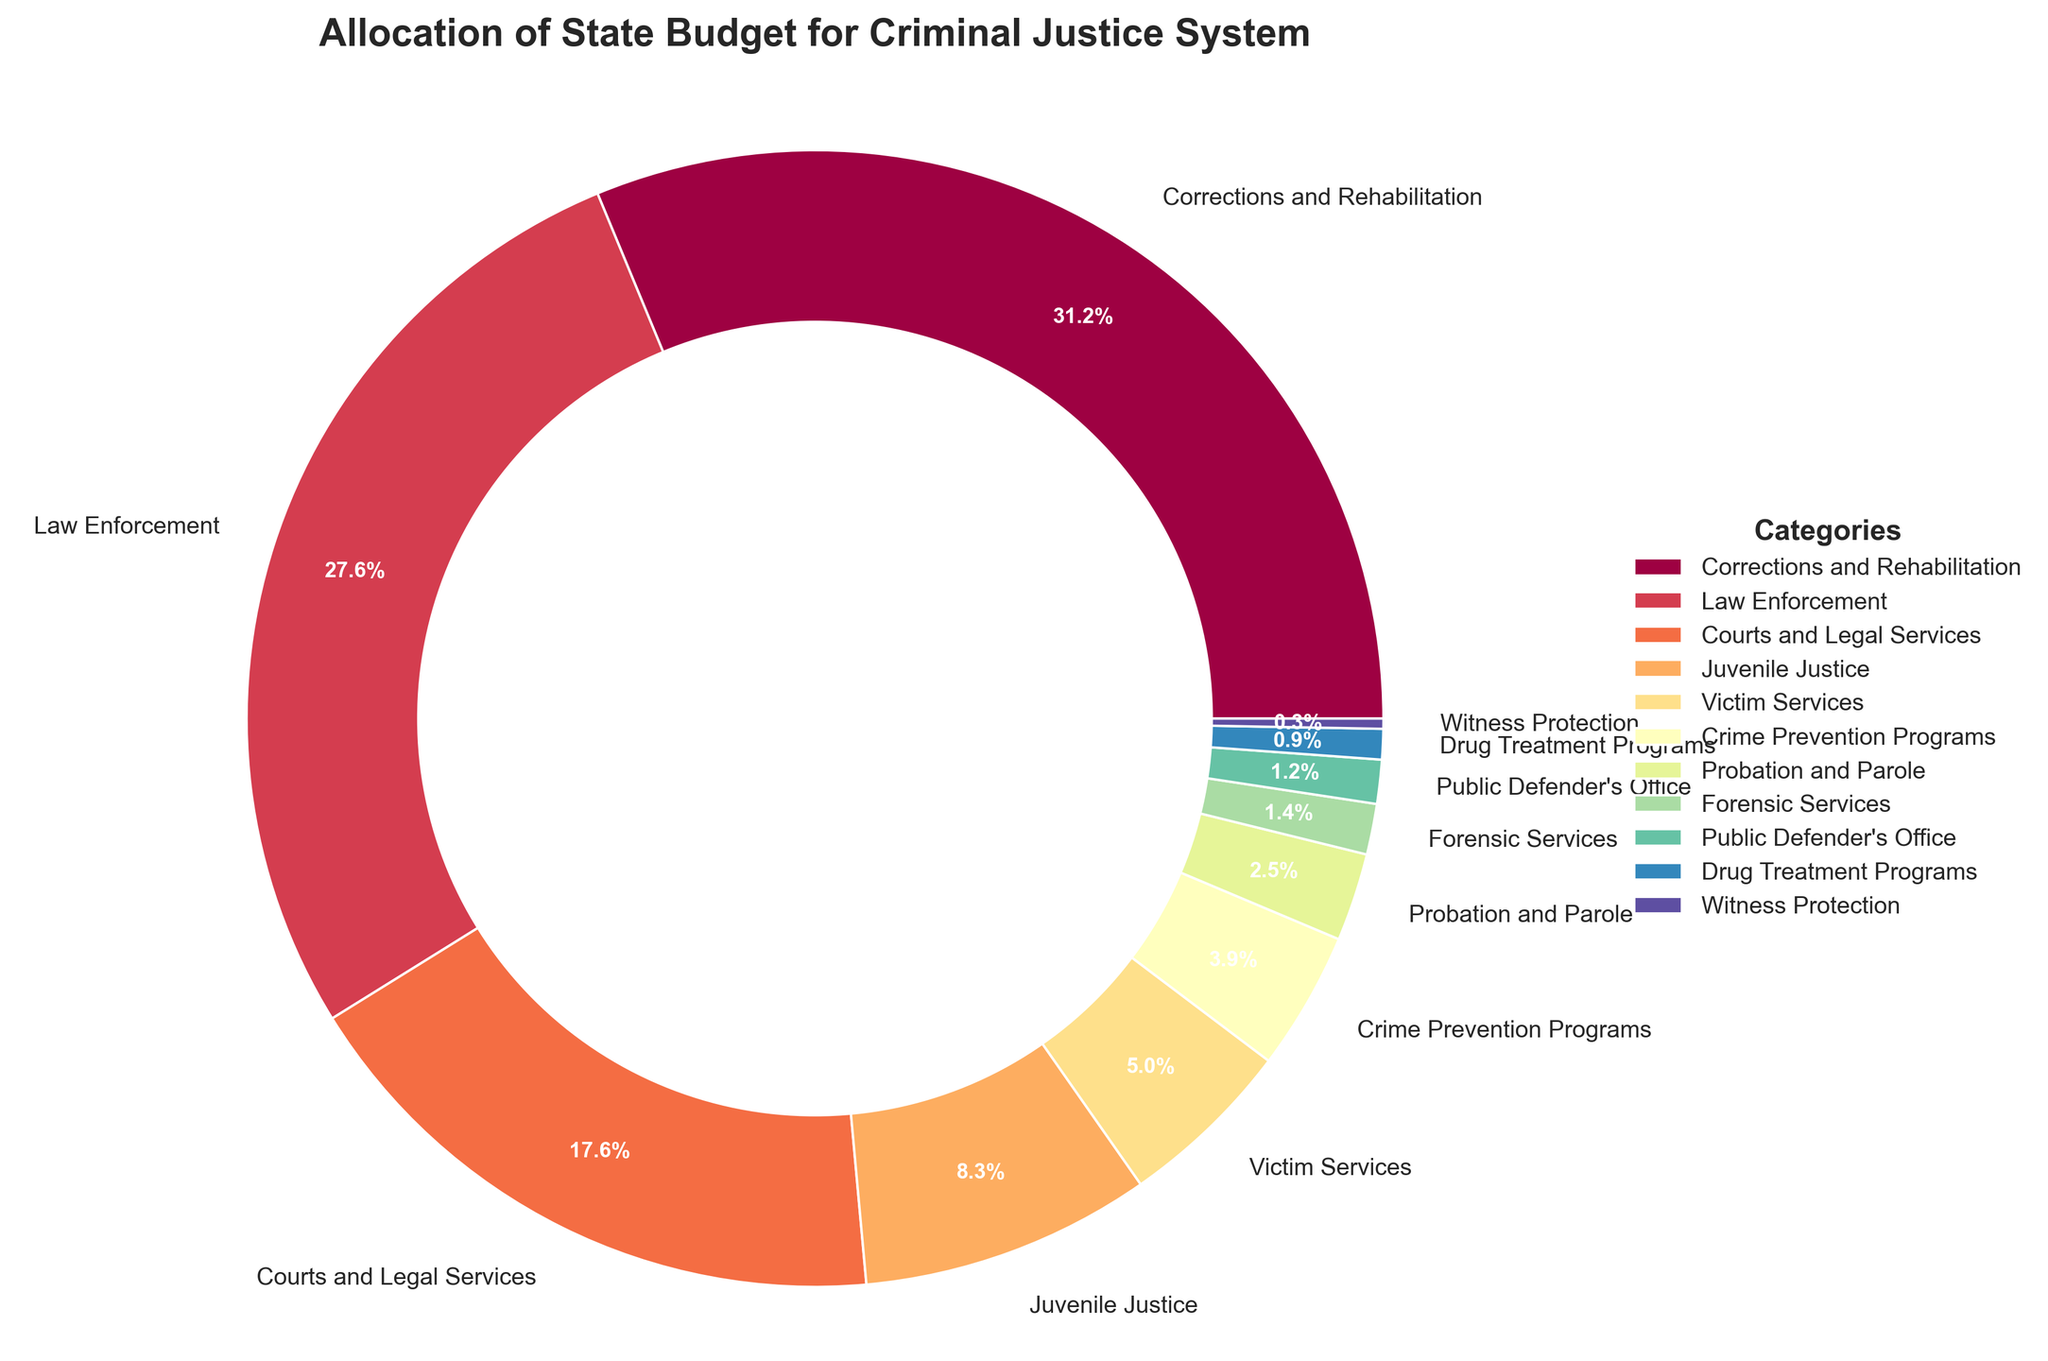What's the largest allocation in the state budget for the criminal justice system? The figure shows that "Corrections and Rehabilitation" has the largest slice of the pie chart with a percentage of 32.5%.
Answer: Corrections and Rehabilitation What is the total percentage allocated to law enforcement and courts and legal services combined? From the figure, Law Enforcement is 28.7% and Courts and Legal Services is 18.3%. Adding these two percentages gives 28.7 + 18.3 = 47%.
Answer: 47% Which category has the smallest allocation, and what is its percentage? According to the figure, "Witness Protection" has the smallest slice of the pie chart with a percentage of 0.3%.
Answer: Witness Protection, 0.3% How much more is allocated to juvenile justice than to probation and parole? Juvenile Justice has an allocation of 8.6%, while Probation and Parole has 2.6%. Subtracting these gives 8.6 - 2.6 = 6%.
Answer: 6% Which category has the second-highest allocation, and what is its percentage? The second-largest slice in the pie chart is "Law Enforcement" with a percentage of 28.7%.
Answer: Law Enforcement, 28.7% Between drug treatment programs and juvenile justice, which has a higher allocation, and by how much? Juvenile Justice is allocated 8.6%, and Drug Treatment Programs is allocated 0.9%. Subtracting these gives 8.6 - 0.9 = 7.7%.
Answer: Juvenile Justice, by 7.7% What percentage of the budget is allocated to categories other than corrections and rehabilitation and law enforcement? Subtracting the percentages of Corrections and Rehabilitation (32.5%) and Law Enforcement (28.7%) from 100% gives 100 - 32.5 - 28.7 = 38.8%.
Answer: 38.8% Which categories collectively account for less than 10% of the budget? From the figure, the categories with allocations adding up to less than 10% are Public Defender's Office (1.3%), Drug Treatment Programs (0.9%), and Witness Protection (0.3%), adding to a total of 2.5%, which is less than 10%.
Answer: Public Defender's Office, Drug Treatment Programs, Witness Protection 